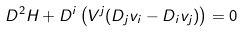Convert formula to latex. <formula><loc_0><loc_0><loc_500><loc_500>D ^ { 2 } H + D ^ { i } \left ( V ^ { j } ( D _ { j } v _ { i } - D _ { i } v _ { j } ) \right ) = 0</formula> 